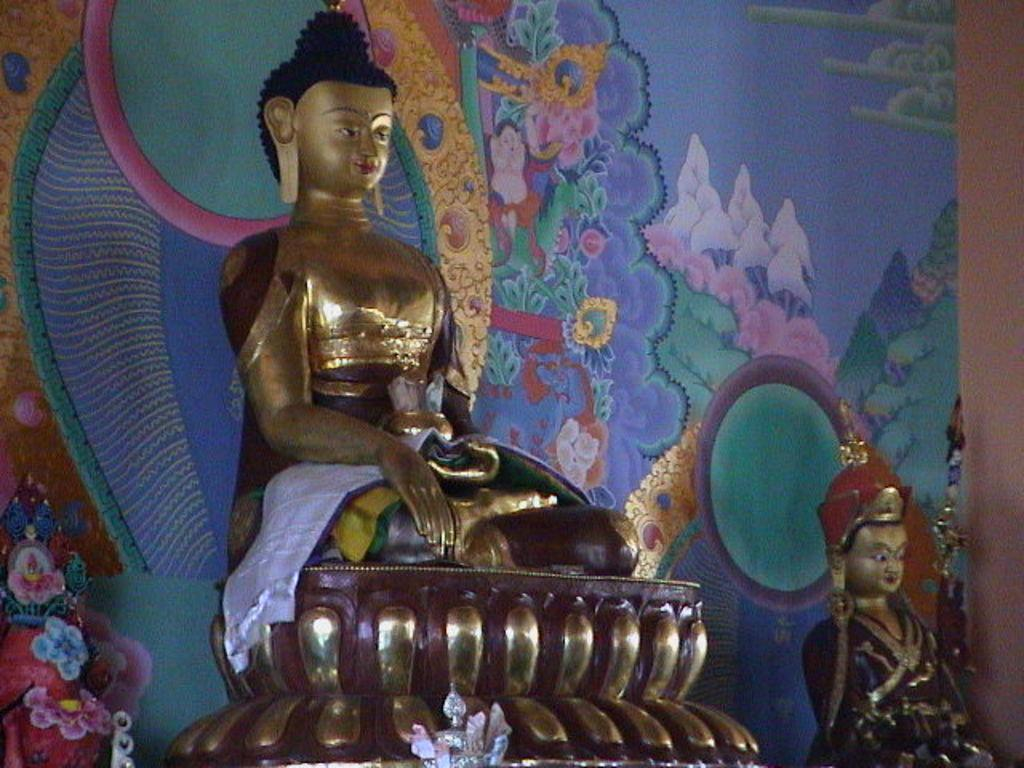What type of art is present in the image? There are sculptures in the image. How many dogs are participating in the voyage depicted in the sculptures? There are no dogs or voyages depicted in the sculptures; the image only features sculptures. 